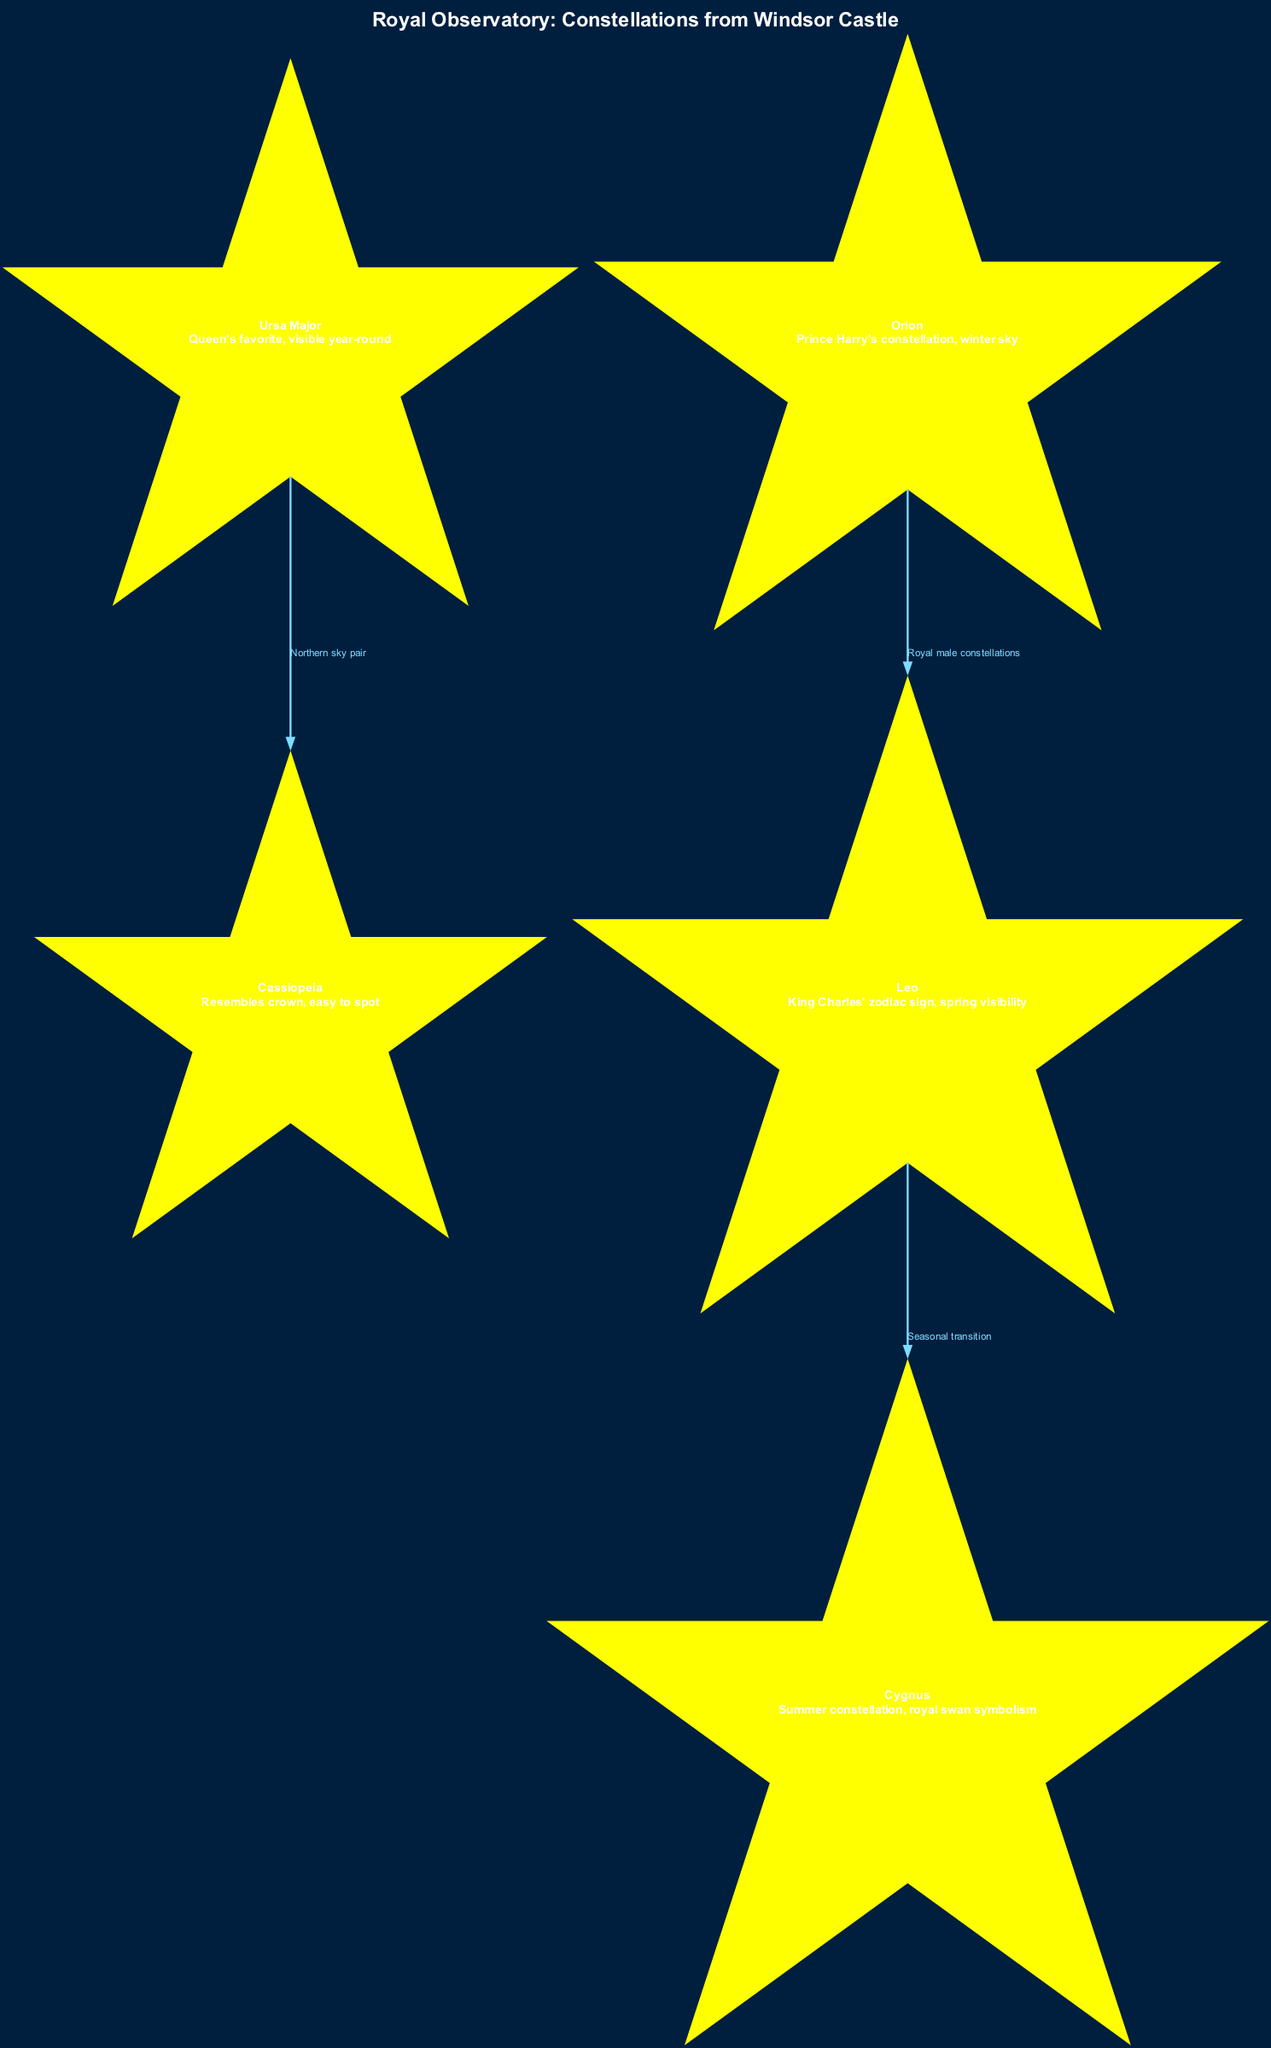What is the title of the diagram? The title of the diagram is explicitly shown at the top. It is "Royal Observatory: Constellations from Windsor Castle".
Answer: Royal Observatory: Constellations from Windsor Castle How many constellations are listed in the diagram? By counting the nodes presented, there are five constellations in total named in the diagram.
Answer: 5 Which constellation is described as resembling a crown? The description of a constellation that resembles a crown specifically points to Cassiopeia.
Answer: Cassiopeia What is the connection between Ursa Major and Cassiopeia? The diagram indicates that they are connected by the label "Northern sky pair", demonstrating a relationship.
Answer: Northern sky pair Which constellation is associated with King Charles? The diagram shows that Leo is specified as King Charles' zodiac sign.
Answer: Leo What is the seasonal visibility pattern for Leo? The description associated with Leo indicates that it is visible in the spring, linking the time of year to the constellation.
Answer: Spring visibility How many edges connect the constellations in the diagram? The edges represent the connections between the nodes, and there are three distinct edges shown in the diagram.
Answer: 3 Which constellation is favored by Prince Harry? According to its description in the diagram, the constellation associated with Prince Harry is Orion.
Answer: Orion What does Cygnus symbolize in the diagram? The description for Cygnus mentions "royal swan symbolism," highlighting its thematic connection.
Answer: Royal swan symbolism 